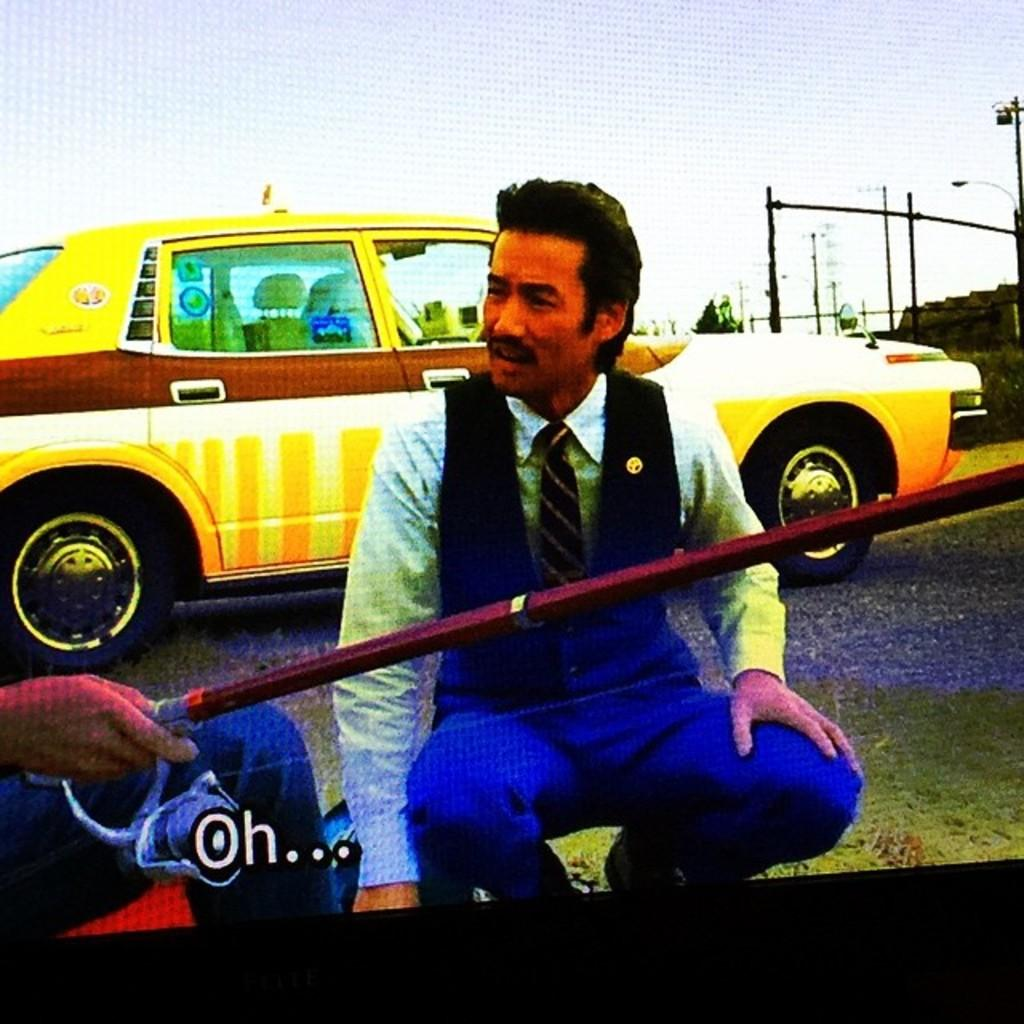Provide a one-sentence caption for the provided image. A TV show's subtitles appear with the exclamatuion, "Oh.". 